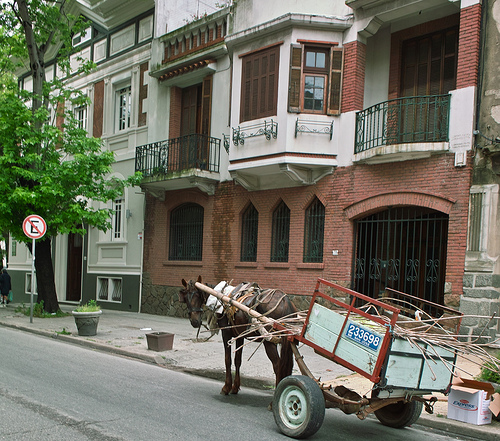Please transcribe the text information in this image. 233698 E 